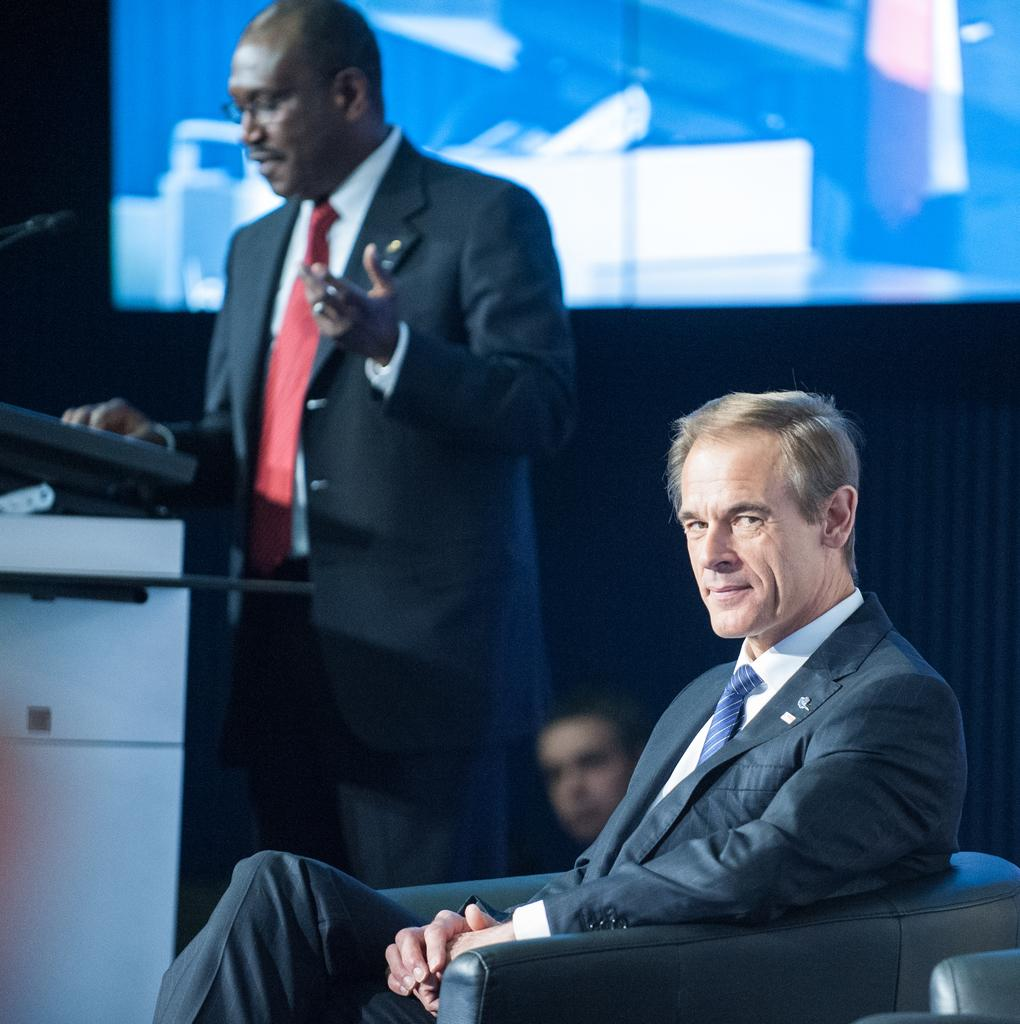How many people are in the image? There are people in the image. What is the position of one of the men in the image? A man is sitting on a sofa chair. What is the other man in the image doing? Another man is standing beside the sitting man. What can be seen in the background of the image? There is a screen visible in the background. What type of garden can be seen in the image? There is no garden present in the image. How many circles are visible in the image? There is no mention of circles in the provided facts, so it cannot be determined from the image. 